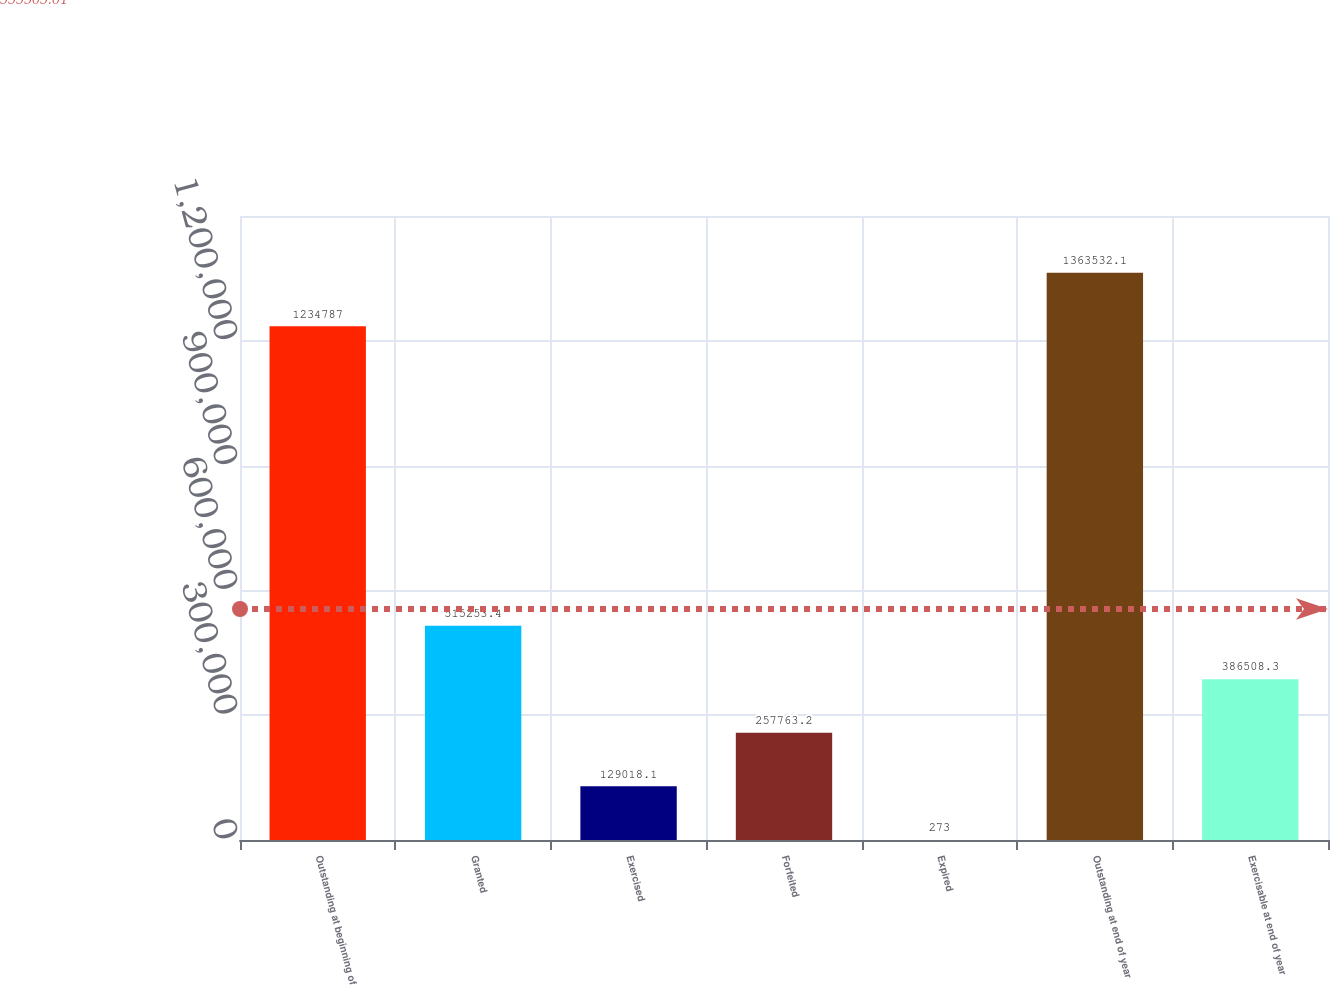Convert chart to OTSL. <chart><loc_0><loc_0><loc_500><loc_500><bar_chart><fcel>Outstanding at beginning of<fcel>Granted<fcel>Exercised<fcel>Forfeited<fcel>Expired<fcel>Outstanding at end of year<fcel>Exercisable at end of year<nl><fcel>1.23479e+06<fcel>515253<fcel>129018<fcel>257763<fcel>273<fcel>1.36353e+06<fcel>386508<nl></chart> 